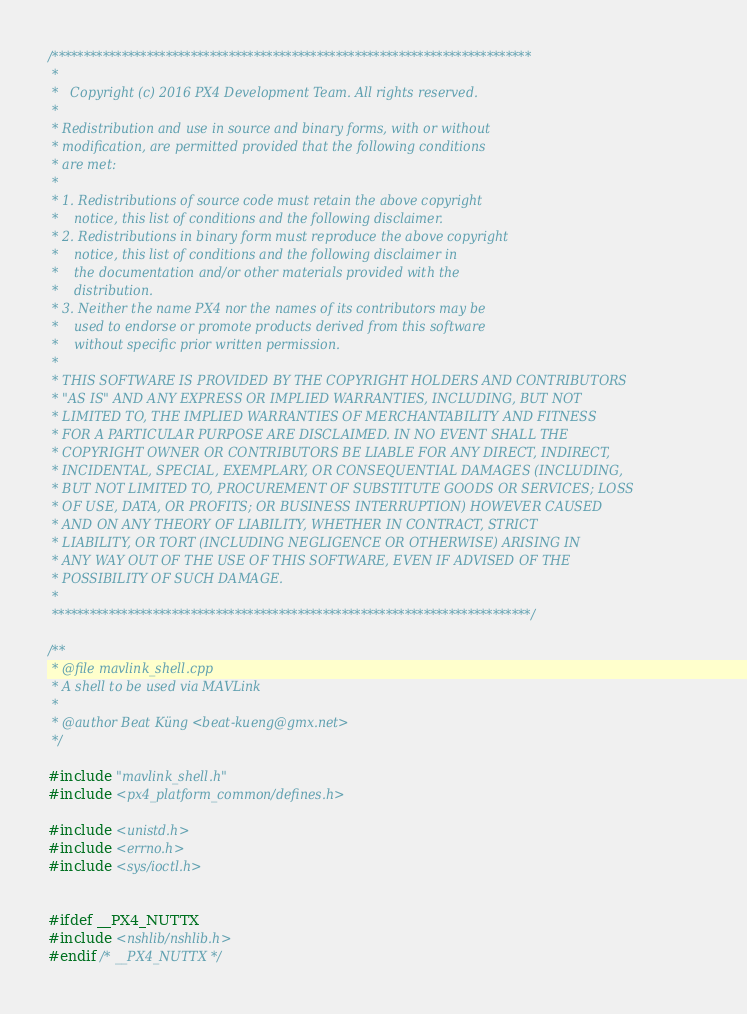Convert code to text. <code><loc_0><loc_0><loc_500><loc_500><_C++_>/****************************************************************************
 *
 *   Copyright (c) 2016 PX4 Development Team. All rights reserved.
 *
 * Redistribution and use in source and binary forms, with or without
 * modification, are permitted provided that the following conditions
 * are met:
 *
 * 1. Redistributions of source code must retain the above copyright
 *    notice, this list of conditions and the following disclaimer.
 * 2. Redistributions in binary form must reproduce the above copyright
 *    notice, this list of conditions and the following disclaimer in
 *    the documentation and/or other materials provided with the
 *    distribution.
 * 3. Neither the name PX4 nor the names of its contributors may be
 *    used to endorse or promote products derived from this software
 *    without specific prior written permission.
 *
 * THIS SOFTWARE IS PROVIDED BY THE COPYRIGHT HOLDERS AND CONTRIBUTORS
 * "AS IS" AND ANY EXPRESS OR IMPLIED WARRANTIES, INCLUDING, BUT NOT
 * LIMITED TO, THE IMPLIED WARRANTIES OF MERCHANTABILITY AND FITNESS
 * FOR A PARTICULAR PURPOSE ARE DISCLAIMED. IN NO EVENT SHALL THE
 * COPYRIGHT OWNER OR CONTRIBUTORS BE LIABLE FOR ANY DIRECT, INDIRECT,
 * INCIDENTAL, SPECIAL, EXEMPLARY, OR CONSEQUENTIAL DAMAGES (INCLUDING,
 * BUT NOT LIMITED TO, PROCUREMENT OF SUBSTITUTE GOODS OR SERVICES; LOSS
 * OF USE, DATA, OR PROFITS; OR BUSINESS INTERRUPTION) HOWEVER CAUSED
 * AND ON ANY THEORY OF LIABILITY, WHETHER IN CONTRACT, STRICT
 * LIABILITY, OR TORT (INCLUDING NEGLIGENCE OR OTHERWISE) ARISING IN
 * ANY WAY OUT OF THE USE OF THIS SOFTWARE, EVEN IF ADVISED OF THE
 * POSSIBILITY OF SUCH DAMAGE.
 *
 ****************************************************************************/

/**
 * @file mavlink_shell.cpp
 * A shell to be used via MAVLink
 *
 * @author Beat Küng <beat-kueng@gmx.net>
 */

#include "mavlink_shell.h"
#include <px4_platform_common/defines.h>

#include <unistd.h>
#include <errno.h>
#include <sys/ioctl.h>


#ifdef __PX4_NUTTX
#include <nshlib/nshlib.h>
#endif /* __PX4_NUTTX */
</code> 